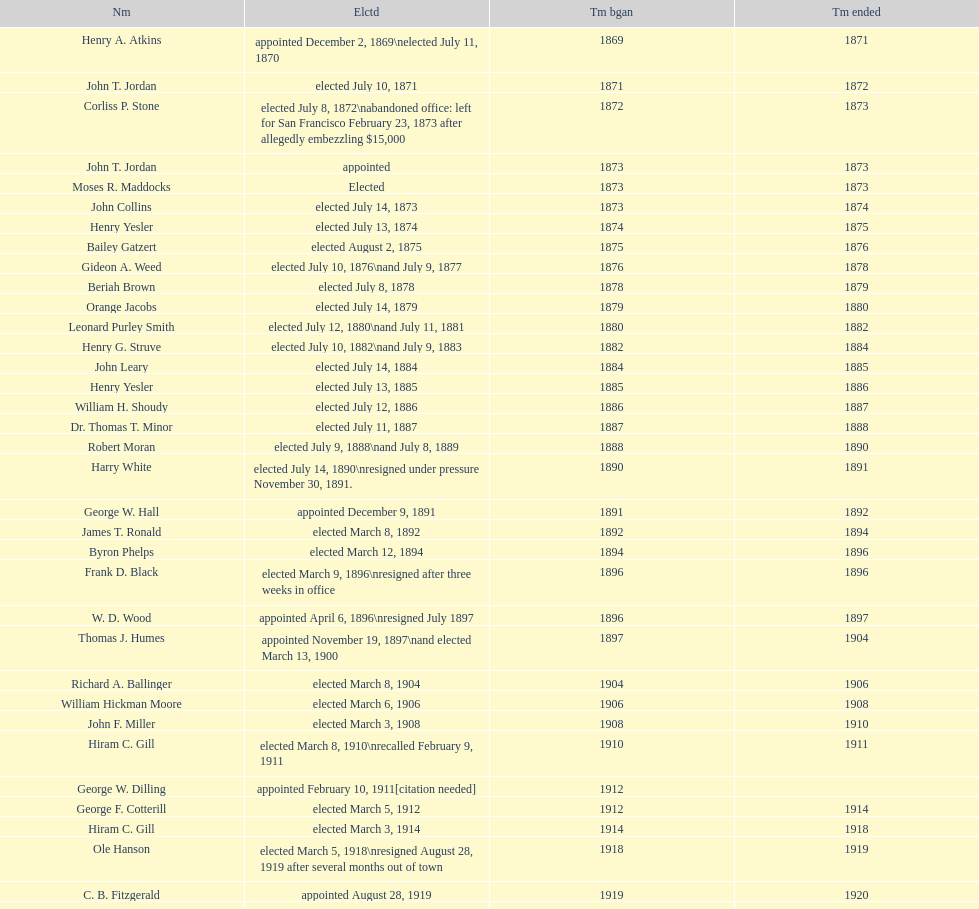Which seattle, washington mayor stepped down after just three weeks in office in 1896? Frank D. Black. 